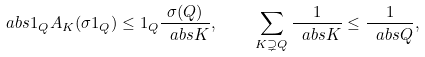<formula> <loc_0><loc_0><loc_500><loc_500>\ a b s { 1 _ { Q } A _ { K } ( \sigma 1 _ { Q } ) } \leq 1 _ { Q } \frac { \sigma ( Q ) } { \ a b s { K } } , \quad \sum _ { K \supsetneq Q } \frac { 1 } { \ a b s { K } } \leq \frac { 1 } { \ a b s { Q } } ,</formula> 